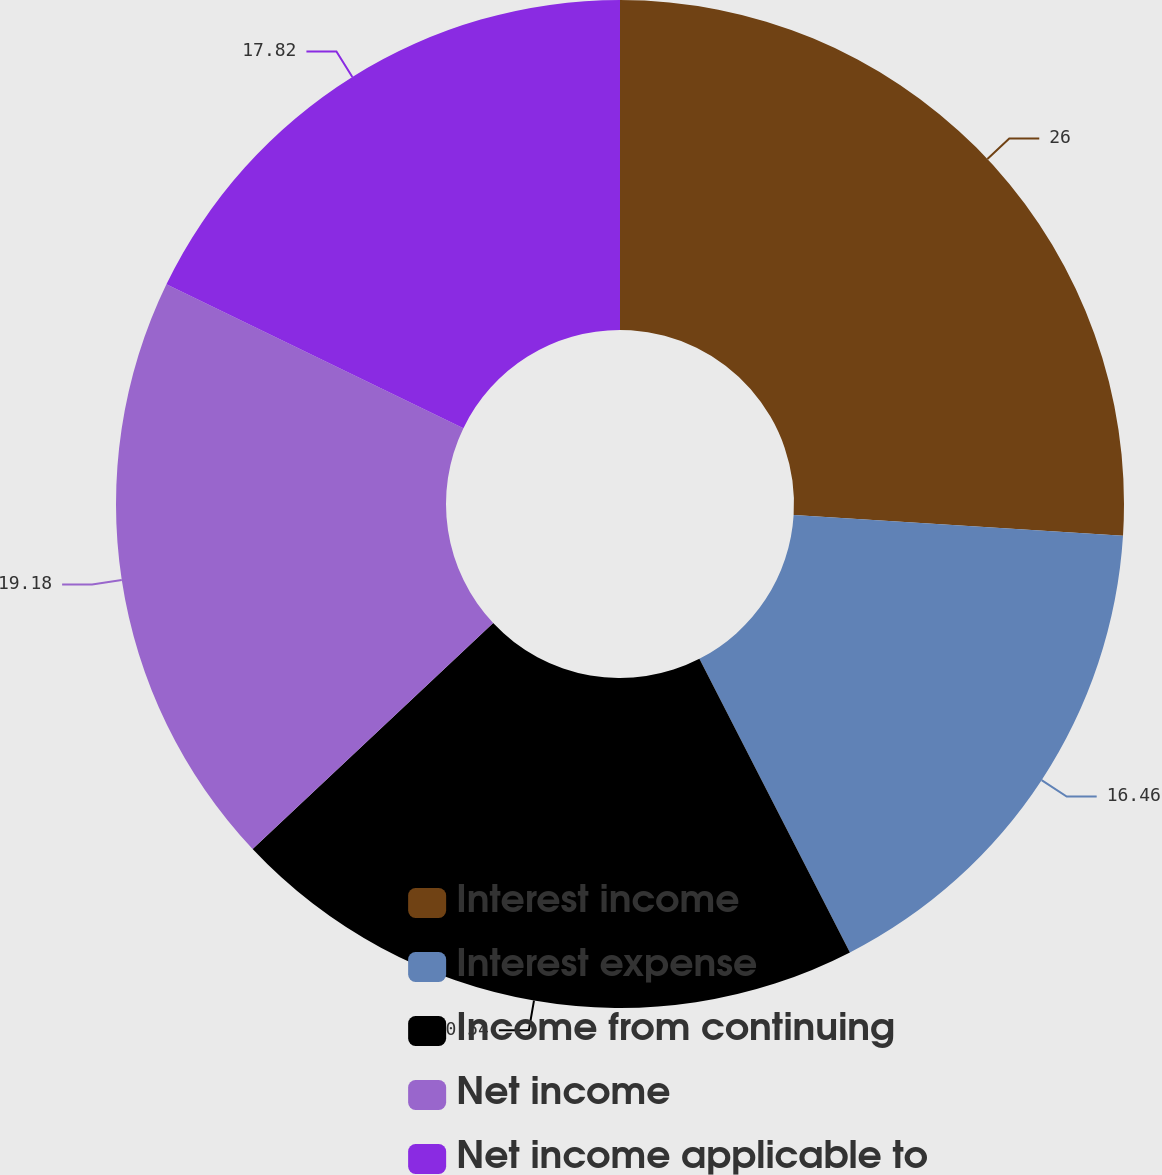<chart> <loc_0><loc_0><loc_500><loc_500><pie_chart><fcel>Interest income<fcel>Interest expense<fcel>Income from continuing<fcel>Net income<fcel>Net income applicable to<nl><fcel>26.0%<fcel>16.46%<fcel>20.54%<fcel>19.18%<fcel>17.82%<nl></chart> 